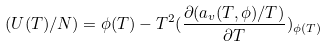<formula> <loc_0><loc_0><loc_500><loc_500>( U ( T ) / N ) = \phi ( T ) - T ^ { 2 } ( \frac { \partial ( a _ { v } ( T , \phi ) / T ) } { \partial T } ) _ { \phi ( T ) }</formula> 